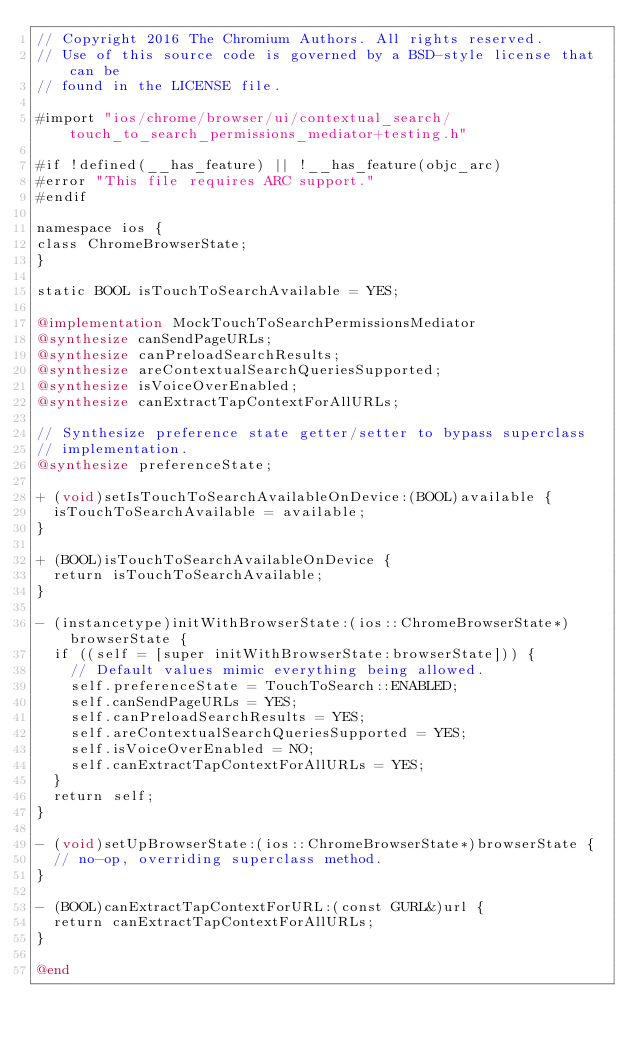Convert code to text. <code><loc_0><loc_0><loc_500><loc_500><_ObjectiveC_>// Copyright 2016 The Chromium Authors. All rights reserved.
// Use of this source code is governed by a BSD-style license that can be
// found in the LICENSE file.

#import "ios/chrome/browser/ui/contextual_search/touch_to_search_permissions_mediator+testing.h"

#if !defined(__has_feature) || !__has_feature(objc_arc)
#error "This file requires ARC support."
#endif

namespace ios {
class ChromeBrowserState;
}

static BOOL isTouchToSearchAvailable = YES;

@implementation MockTouchToSearchPermissionsMediator
@synthesize canSendPageURLs;
@synthesize canPreloadSearchResults;
@synthesize areContextualSearchQueriesSupported;
@synthesize isVoiceOverEnabled;
@synthesize canExtractTapContextForAllURLs;

// Synthesize preference state getter/setter to bypass superclass
// implementation.
@synthesize preferenceState;

+ (void)setIsTouchToSearchAvailableOnDevice:(BOOL)available {
  isTouchToSearchAvailable = available;
}

+ (BOOL)isTouchToSearchAvailableOnDevice {
  return isTouchToSearchAvailable;
}

- (instancetype)initWithBrowserState:(ios::ChromeBrowserState*)browserState {
  if ((self = [super initWithBrowserState:browserState])) {
    // Default values mimic everything being allowed.
    self.preferenceState = TouchToSearch::ENABLED;
    self.canSendPageURLs = YES;
    self.canPreloadSearchResults = YES;
    self.areContextualSearchQueriesSupported = YES;
    self.isVoiceOverEnabled = NO;
    self.canExtractTapContextForAllURLs = YES;
  }
  return self;
}

- (void)setUpBrowserState:(ios::ChromeBrowserState*)browserState {
  // no-op, overriding superclass method.
}

- (BOOL)canExtractTapContextForURL:(const GURL&)url {
  return canExtractTapContextForAllURLs;
}

@end
</code> 